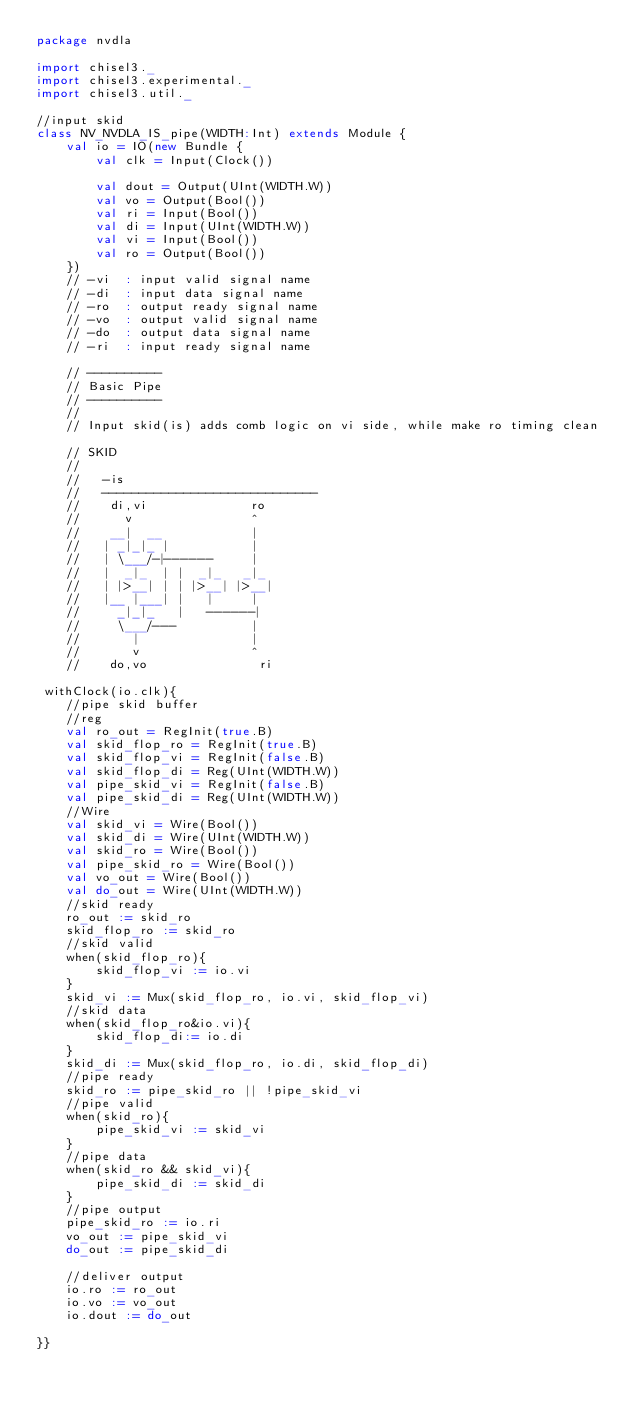Convert code to text. <code><loc_0><loc_0><loc_500><loc_500><_Scala_>package nvdla

import chisel3._
import chisel3.experimental._
import chisel3.util._

//input skid
class NV_NVDLA_IS_pipe(WIDTH:Int) extends Module {
    val io = IO(new Bundle {  
        val clk = Input(Clock())  

        val dout = Output(UInt(WIDTH.W))
        val vo = Output(Bool())
        val ri = Input(Bool())
        val di = Input(UInt(WIDTH.W))
        val vi = Input(Bool())
        val ro = Output(Bool())
    })
    // -vi  : input valid signal name
    // -di  : input data signal name
    // -ro  : output ready signal name
    // -vo  : output valid signal name
    // -do  : output data signal name
    // -ri  : input ready signal name

    // ----------
    // Basic Pipe
    // ----------
    // 
    // Input skid(is) adds comb logic on vi side, while make ro timing clean
        
    // SKID
    //
    //   -is                           
    //   ----------------------------- 
    //    di,vi              ro       
    //      v                ^        
    //    __|  __            |        
    //   | _|_|_ |           |        
    //   | \___/-|------     |        
    //   |  _|_  | |  _|_   _|_       
    //   | |>__| | | |>__| |>__|      
    //   |__ |___| |   |     |        
    //     _|_|_   |   ------|        
    //     \___/---          |           
    //       |               |        
    //       v               ^        
    //    do,vo               ri   
  
 withClock(io.clk){       
    //pipe skid buffer
    //reg
    val ro_out = RegInit(true.B)
    val skid_flop_ro = RegInit(true.B)
    val skid_flop_vi = RegInit(false.B)
    val skid_flop_di = Reg(UInt(WIDTH.W))
    val pipe_skid_vi = RegInit(false.B)
    val pipe_skid_di = Reg(UInt(WIDTH.W))
    //Wire
    val skid_vi = Wire(Bool())
    val skid_di = Wire(UInt(WIDTH.W))
    val skid_ro = Wire(Bool())
    val pipe_skid_ro = Wire(Bool())
    val vo_out = Wire(Bool())
    val do_out = Wire(UInt(WIDTH.W))
    //skid ready
    ro_out := skid_ro
    skid_flop_ro := skid_ro
    //skid valid
    when(skid_flop_ro){
        skid_flop_vi := io.vi
    }
    skid_vi := Mux(skid_flop_ro, io.vi, skid_flop_vi)
    //skid data
    when(skid_flop_ro&io.vi){
        skid_flop_di:= io.di
    }
    skid_di := Mux(skid_flop_ro, io.di, skid_flop_di)
    //pipe ready
    skid_ro := pipe_skid_ro || !pipe_skid_vi
    //pipe valid
    when(skid_ro){
        pipe_skid_vi := skid_vi
    }
    //pipe data
    when(skid_ro && skid_vi){
        pipe_skid_di := skid_di
    }
    //pipe output
    pipe_skid_ro := io.ri
    vo_out := pipe_skid_vi
    do_out := pipe_skid_di

    //deliver output
    io.ro := ro_out
    io.vo := vo_out
    io.dout := do_out
          
}}
</code> 